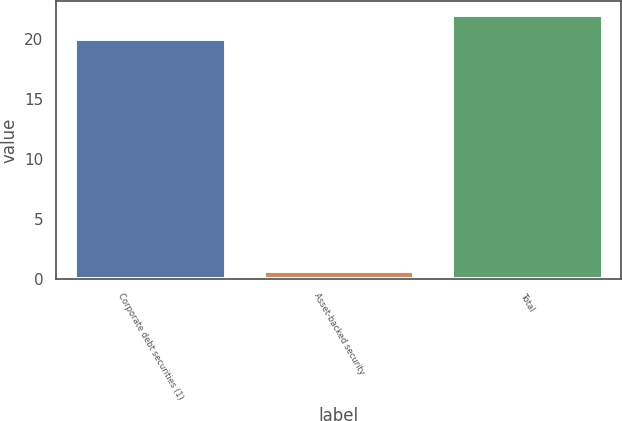Convert chart. <chart><loc_0><loc_0><loc_500><loc_500><bar_chart><fcel>Corporate debt securities (1)<fcel>Asset-backed security<fcel>Total<nl><fcel>20<fcel>0.6<fcel>22<nl></chart> 